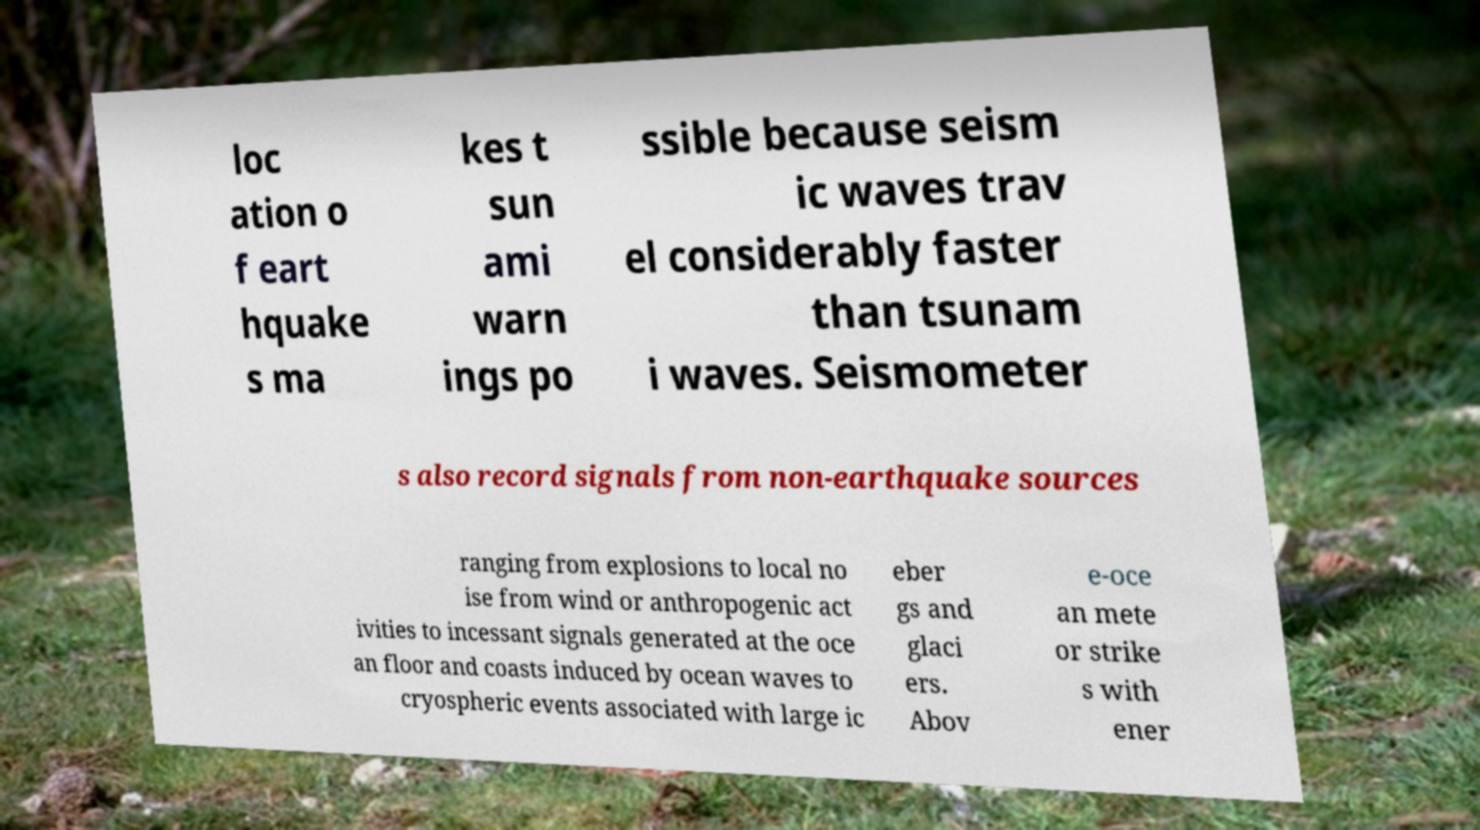There's text embedded in this image that I need extracted. Can you transcribe it verbatim? loc ation o f eart hquake s ma kes t sun ami warn ings po ssible because seism ic waves trav el considerably faster than tsunam i waves. Seismometer s also record signals from non-earthquake sources ranging from explosions to local no ise from wind or anthropogenic act ivities to incessant signals generated at the oce an floor and coasts induced by ocean waves to cryospheric events associated with large ic eber gs and glaci ers. Abov e-oce an mete or strike s with ener 